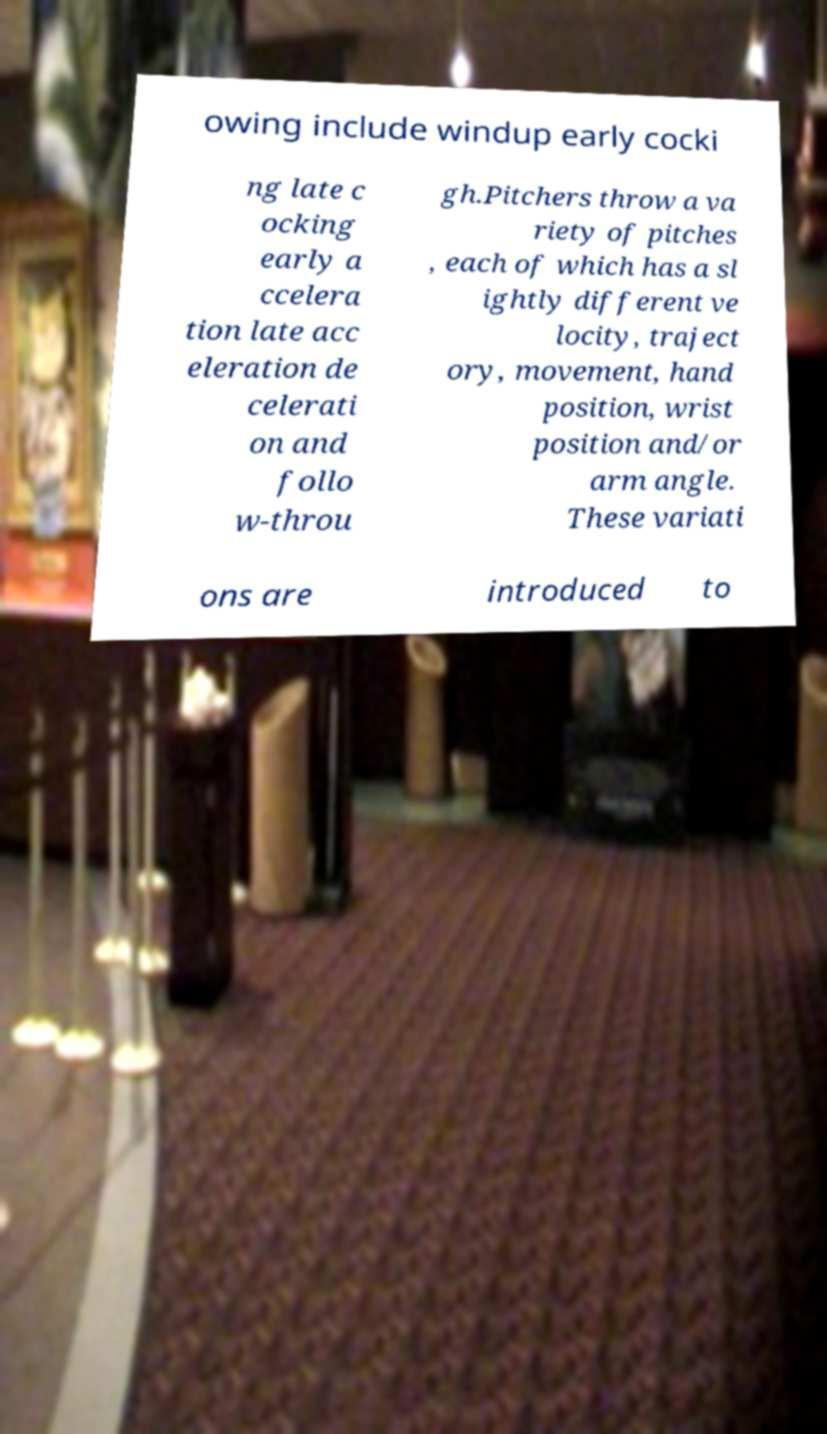There's text embedded in this image that I need extracted. Can you transcribe it verbatim? owing include windup early cocki ng late c ocking early a ccelera tion late acc eleration de celerati on and follo w-throu gh.Pitchers throw a va riety of pitches , each of which has a sl ightly different ve locity, traject ory, movement, hand position, wrist position and/or arm angle. These variati ons are introduced to 